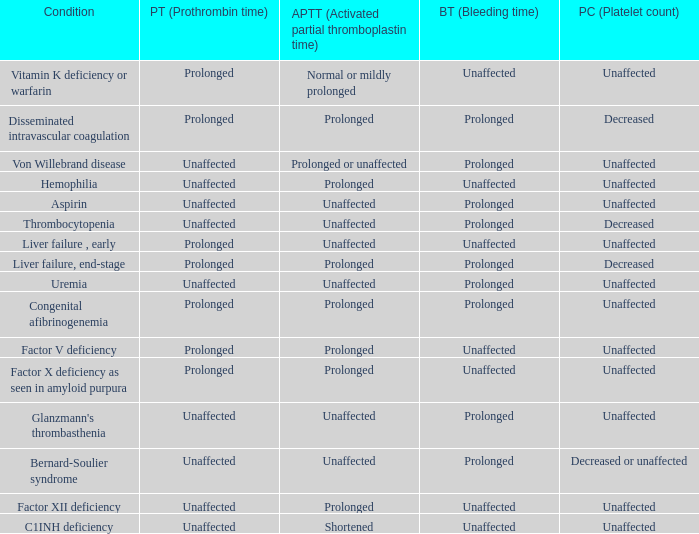Which Platelet count has a Condition of factor v deficiency? Unaffected. 